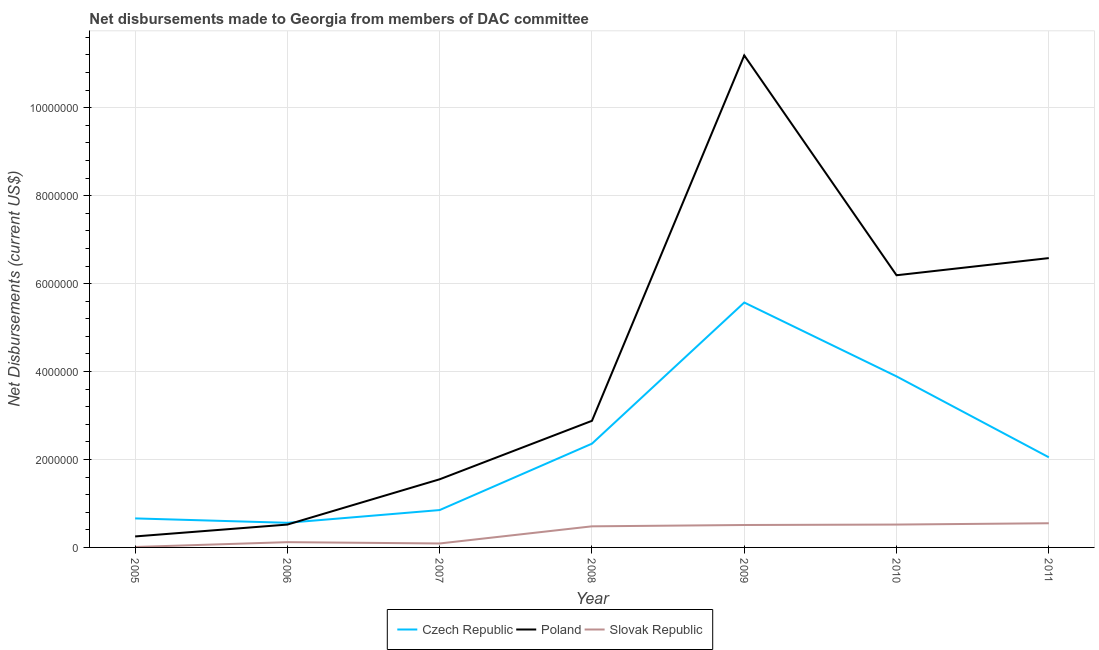What is the net disbursements made by czech republic in 2005?
Offer a terse response. 6.60e+05. Across all years, what is the maximum net disbursements made by czech republic?
Make the answer very short. 5.57e+06. Across all years, what is the minimum net disbursements made by poland?
Offer a very short reply. 2.50e+05. In which year was the net disbursements made by poland maximum?
Your response must be concise. 2009. In which year was the net disbursements made by poland minimum?
Offer a terse response. 2005. What is the total net disbursements made by czech republic in the graph?
Your answer should be very brief. 1.59e+07. What is the difference between the net disbursements made by poland in 2007 and that in 2009?
Keep it short and to the point. -9.64e+06. What is the difference between the net disbursements made by slovak republic in 2010 and the net disbursements made by poland in 2006?
Offer a terse response. 0. What is the average net disbursements made by poland per year?
Your response must be concise. 4.17e+06. In the year 2010, what is the difference between the net disbursements made by poland and net disbursements made by slovak republic?
Make the answer very short. 5.67e+06. What is the ratio of the net disbursements made by poland in 2008 to that in 2009?
Make the answer very short. 0.26. Is the net disbursements made by slovak republic in 2006 less than that in 2008?
Make the answer very short. Yes. Is the difference between the net disbursements made by slovak republic in 2009 and 2011 greater than the difference between the net disbursements made by czech republic in 2009 and 2011?
Provide a short and direct response. No. What is the difference between the highest and the second highest net disbursements made by slovak republic?
Your answer should be very brief. 3.00e+04. What is the difference between the highest and the lowest net disbursements made by slovak republic?
Provide a short and direct response. 5.40e+05. Is the sum of the net disbursements made by slovak republic in 2009 and 2010 greater than the maximum net disbursements made by czech republic across all years?
Offer a terse response. No. Is the net disbursements made by poland strictly less than the net disbursements made by slovak republic over the years?
Offer a terse response. No. How many years are there in the graph?
Ensure brevity in your answer.  7. Where does the legend appear in the graph?
Provide a succinct answer. Bottom center. How are the legend labels stacked?
Keep it short and to the point. Horizontal. What is the title of the graph?
Provide a short and direct response. Net disbursements made to Georgia from members of DAC committee. What is the label or title of the X-axis?
Give a very brief answer. Year. What is the label or title of the Y-axis?
Your answer should be very brief. Net Disbursements (current US$). What is the Net Disbursements (current US$) in Czech Republic in 2005?
Offer a terse response. 6.60e+05. What is the Net Disbursements (current US$) of Slovak Republic in 2005?
Provide a succinct answer. 10000. What is the Net Disbursements (current US$) in Czech Republic in 2006?
Give a very brief answer. 5.60e+05. What is the Net Disbursements (current US$) of Poland in 2006?
Provide a short and direct response. 5.20e+05. What is the Net Disbursements (current US$) of Slovak Republic in 2006?
Keep it short and to the point. 1.20e+05. What is the Net Disbursements (current US$) in Czech Republic in 2007?
Your answer should be very brief. 8.50e+05. What is the Net Disbursements (current US$) of Poland in 2007?
Offer a terse response. 1.55e+06. What is the Net Disbursements (current US$) in Czech Republic in 2008?
Your answer should be compact. 2.36e+06. What is the Net Disbursements (current US$) in Poland in 2008?
Offer a terse response. 2.88e+06. What is the Net Disbursements (current US$) in Slovak Republic in 2008?
Your answer should be compact. 4.80e+05. What is the Net Disbursements (current US$) in Czech Republic in 2009?
Your answer should be compact. 5.57e+06. What is the Net Disbursements (current US$) in Poland in 2009?
Ensure brevity in your answer.  1.12e+07. What is the Net Disbursements (current US$) in Slovak Republic in 2009?
Provide a succinct answer. 5.10e+05. What is the Net Disbursements (current US$) in Czech Republic in 2010?
Offer a very short reply. 3.89e+06. What is the Net Disbursements (current US$) of Poland in 2010?
Offer a very short reply. 6.19e+06. What is the Net Disbursements (current US$) of Slovak Republic in 2010?
Offer a very short reply. 5.20e+05. What is the Net Disbursements (current US$) of Czech Republic in 2011?
Keep it short and to the point. 2.05e+06. What is the Net Disbursements (current US$) in Poland in 2011?
Offer a very short reply. 6.58e+06. What is the Net Disbursements (current US$) of Slovak Republic in 2011?
Keep it short and to the point. 5.50e+05. Across all years, what is the maximum Net Disbursements (current US$) of Czech Republic?
Your answer should be compact. 5.57e+06. Across all years, what is the maximum Net Disbursements (current US$) of Poland?
Keep it short and to the point. 1.12e+07. Across all years, what is the maximum Net Disbursements (current US$) of Slovak Republic?
Your answer should be compact. 5.50e+05. Across all years, what is the minimum Net Disbursements (current US$) of Czech Republic?
Provide a short and direct response. 5.60e+05. Across all years, what is the minimum Net Disbursements (current US$) in Poland?
Your answer should be very brief. 2.50e+05. Across all years, what is the minimum Net Disbursements (current US$) of Slovak Republic?
Make the answer very short. 10000. What is the total Net Disbursements (current US$) of Czech Republic in the graph?
Ensure brevity in your answer.  1.59e+07. What is the total Net Disbursements (current US$) in Poland in the graph?
Your response must be concise. 2.92e+07. What is the total Net Disbursements (current US$) of Slovak Republic in the graph?
Ensure brevity in your answer.  2.28e+06. What is the difference between the Net Disbursements (current US$) in Poland in 2005 and that in 2006?
Offer a terse response. -2.70e+05. What is the difference between the Net Disbursements (current US$) in Poland in 2005 and that in 2007?
Your answer should be very brief. -1.30e+06. What is the difference between the Net Disbursements (current US$) in Czech Republic in 2005 and that in 2008?
Your response must be concise. -1.70e+06. What is the difference between the Net Disbursements (current US$) of Poland in 2005 and that in 2008?
Give a very brief answer. -2.63e+06. What is the difference between the Net Disbursements (current US$) in Slovak Republic in 2005 and that in 2008?
Your response must be concise. -4.70e+05. What is the difference between the Net Disbursements (current US$) in Czech Republic in 2005 and that in 2009?
Your answer should be very brief. -4.91e+06. What is the difference between the Net Disbursements (current US$) in Poland in 2005 and that in 2009?
Provide a short and direct response. -1.09e+07. What is the difference between the Net Disbursements (current US$) in Slovak Republic in 2005 and that in 2009?
Your answer should be very brief. -5.00e+05. What is the difference between the Net Disbursements (current US$) of Czech Republic in 2005 and that in 2010?
Your response must be concise. -3.23e+06. What is the difference between the Net Disbursements (current US$) of Poland in 2005 and that in 2010?
Provide a short and direct response. -5.94e+06. What is the difference between the Net Disbursements (current US$) in Slovak Republic in 2005 and that in 2010?
Give a very brief answer. -5.10e+05. What is the difference between the Net Disbursements (current US$) in Czech Republic in 2005 and that in 2011?
Offer a terse response. -1.39e+06. What is the difference between the Net Disbursements (current US$) in Poland in 2005 and that in 2011?
Offer a terse response. -6.33e+06. What is the difference between the Net Disbursements (current US$) of Slovak Republic in 2005 and that in 2011?
Provide a succinct answer. -5.40e+05. What is the difference between the Net Disbursements (current US$) in Czech Republic in 2006 and that in 2007?
Make the answer very short. -2.90e+05. What is the difference between the Net Disbursements (current US$) in Poland in 2006 and that in 2007?
Provide a succinct answer. -1.03e+06. What is the difference between the Net Disbursements (current US$) in Slovak Republic in 2006 and that in 2007?
Ensure brevity in your answer.  3.00e+04. What is the difference between the Net Disbursements (current US$) of Czech Republic in 2006 and that in 2008?
Give a very brief answer. -1.80e+06. What is the difference between the Net Disbursements (current US$) in Poland in 2006 and that in 2008?
Offer a very short reply. -2.36e+06. What is the difference between the Net Disbursements (current US$) of Slovak Republic in 2006 and that in 2008?
Offer a very short reply. -3.60e+05. What is the difference between the Net Disbursements (current US$) of Czech Republic in 2006 and that in 2009?
Your answer should be compact. -5.01e+06. What is the difference between the Net Disbursements (current US$) in Poland in 2006 and that in 2009?
Offer a terse response. -1.07e+07. What is the difference between the Net Disbursements (current US$) in Slovak Republic in 2006 and that in 2009?
Your response must be concise. -3.90e+05. What is the difference between the Net Disbursements (current US$) in Czech Republic in 2006 and that in 2010?
Offer a terse response. -3.33e+06. What is the difference between the Net Disbursements (current US$) of Poland in 2006 and that in 2010?
Give a very brief answer. -5.67e+06. What is the difference between the Net Disbursements (current US$) of Slovak Republic in 2006 and that in 2010?
Your response must be concise. -4.00e+05. What is the difference between the Net Disbursements (current US$) in Czech Republic in 2006 and that in 2011?
Keep it short and to the point. -1.49e+06. What is the difference between the Net Disbursements (current US$) in Poland in 2006 and that in 2011?
Give a very brief answer. -6.06e+06. What is the difference between the Net Disbursements (current US$) in Slovak Republic in 2006 and that in 2011?
Give a very brief answer. -4.30e+05. What is the difference between the Net Disbursements (current US$) of Czech Republic in 2007 and that in 2008?
Keep it short and to the point. -1.51e+06. What is the difference between the Net Disbursements (current US$) in Poland in 2007 and that in 2008?
Offer a terse response. -1.33e+06. What is the difference between the Net Disbursements (current US$) in Slovak Republic in 2007 and that in 2008?
Make the answer very short. -3.90e+05. What is the difference between the Net Disbursements (current US$) of Czech Republic in 2007 and that in 2009?
Make the answer very short. -4.72e+06. What is the difference between the Net Disbursements (current US$) of Poland in 2007 and that in 2009?
Your response must be concise. -9.64e+06. What is the difference between the Net Disbursements (current US$) in Slovak Republic in 2007 and that in 2009?
Provide a short and direct response. -4.20e+05. What is the difference between the Net Disbursements (current US$) in Czech Republic in 2007 and that in 2010?
Your answer should be very brief. -3.04e+06. What is the difference between the Net Disbursements (current US$) in Poland in 2007 and that in 2010?
Offer a very short reply. -4.64e+06. What is the difference between the Net Disbursements (current US$) of Slovak Republic in 2007 and that in 2010?
Ensure brevity in your answer.  -4.30e+05. What is the difference between the Net Disbursements (current US$) of Czech Republic in 2007 and that in 2011?
Keep it short and to the point. -1.20e+06. What is the difference between the Net Disbursements (current US$) of Poland in 2007 and that in 2011?
Provide a short and direct response. -5.03e+06. What is the difference between the Net Disbursements (current US$) in Slovak Republic in 2007 and that in 2011?
Your answer should be compact. -4.60e+05. What is the difference between the Net Disbursements (current US$) of Czech Republic in 2008 and that in 2009?
Provide a short and direct response. -3.21e+06. What is the difference between the Net Disbursements (current US$) of Poland in 2008 and that in 2009?
Your answer should be compact. -8.31e+06. What is the difference between the Net Disbursements (current US$) of Czech Republic in 2008 and that in 2010?
Keep it short and to the point. -1.53e+06. What is the difference between the Net Disbursements (current US$) of Poland in 2008 and that in 2010?
Offer a terse response. -3.31e+06. What is the difference between the Net Disbursements (current US$) of Slovak Republic in 2008 and that in 2010?
Your answer should be very brief. -4.00e+04. What is the difference between the Net Disbursements (current US$) in Poland in 2008 and that in 2011?
Ensure brevity in your answer.  -3.70e+06. What is the difference between the Net Disbursements (current US$) of Slovak Republic in 2008 and that in 2011?
Provide a succinct answer. -7.00e+04. What is the difference between the Net Disbursements (current US$) of Czech Republic in 2009 and that in 2010?
Your response must be concise. 1.68e+06. What is the difference between the Net Disbursements (current US$) of Czech Republic in 2009 and that in 2011?
Keep it short and to the point. 3.52e+06. What is the difference between the Net Disbursements (current US$) of Poland in 2009 and that in 2011?
Give a very brief answer. 4.61e+06. What is the difference between the Net Disbursements (current US$) of Slovak Republic in 2009 and that in 2011?
Provide a short and direct response. -4.00e+04. What is the difference between the Net Disbursements (current US$) of Czech Republic in 2010 and that in 2011?
Offer a terse response. 1.84e+06. What is the difference between the Net Disbursements (current US$) of Poland in 2010 and that in 2011?
Your response must be concise. -3.90e+05. What is the difference between the Net Disbursements (current US$) in Slovak Republic in 2010 and that in 2011?
Offer a terse response. -3.00e+04. What is the difference between the Net Disbursements (current US$) in Czech Republic in 2005 and the Net Disbursements (current US$) in Poland in 2006?
Your response must be concise. 1.40e+05. What is the difference between the Net Disbursements (current US$) in Czech Republic in 2005 and the Net Disbursements (current US$) in Slovak Republic in 2006?
Provide a short and direct response. 5.40e+05. What is the difference between the Net Disbursements (current US$) of Poland in 2005 and the Net Disbursements (current US$) of Slovak Republic in 2006?
Ensure brevity in your answer.  1.30e+05. What is the difference between the Net Disbursements (current US$) in Czech Republic in 2005 and the Net Disbursements (current US$) in Poland in 2007?
Offer a terse response. -8.90e+05. What is the difference between the Net Disbursements (current US$) of Czech Republic in 2005 and the Net Disbursements (current US$) of Slovak Republic in 2007?
Make the answer very short. 5.70e+05. What is the difference between the Net Disbursements (current US$) of Poland in 2005 and the Net Disbursements (current US$) of Slovak Republic in 2007?
Your answer should be compact. 1.60e+05. What is the difference between the Net Disbursements (current US$) of Czech Republic in 2005 and the Net Disbursements (current US$) of Poland in 2008?
Ensure brevity in your answer.  -2.22e+06. What is the difference between the Net Disbursements (current US$) of Poland in 2005 and the Net Disbursements (current US$) of Slovak Republic in 2008?
Give a very brief answer. -2.30e+05. What is the difference between the Net Disbursements (current US$) in Czech Republic in 2005 and the Net Disbursements (current US$) in Poland in 2009?
Your response must be concise. -1.05e+07. What is the difference between the Net Disbursements (current US$) of Czech Republic in 2005 and the Net Disbursements (current US$) of Poland in 2010?
Make the answer very short. -5.53e+06. What is the difference between the Net Disbursements (current US$) of Czech Republic in 2005 and the Net Disbursements (current US$) of Poland in 2011?
Give a very brief answer. -5.92e+06. What is the difference between the Net Disbursements (current US$) of Czech Republic in 2006 and the Net Disbursements (current US$) of Poland in 2007?
Give a very brief answer. -9.90e+05. What is the difference between the Net Disbursements (current US$) of Poland in 2006 and the Net Disbursements (current US$) of Slovak Republic in 2007?
Ensure brevity in your answer.  4.30e+05. What is the difference between the Net Disbursements (current US$) of Czech Republic in 2006 and the Net Disbursements (current US$) of Poland in 2008?
Provide a short and direct response. -2.32e+06. What is the difference between the Net Disbursements (current US$) of Czech Republic in 2006 and the Net Disbursements (current US$) of Slovak Republic in 2008?
Ensure brevity in your answer.  8.00e+04. What is the difference between the Net Disbursements (current US$) in Czech Republic in 2006 and the Net Disbursements (current US$) in Poland in 2009?
Provide a short and direct response. -1.06e+07. What is the difference between the Net Disbursements (current US$) in Czech Republic in 2006 and the Net Disbursements (current US$) in Poland in 2010?
Give a very brief answer. -5.63e+06. What is the difference between the Net Disbursements (current US$) in Poland in 2006 and the Net Disbursements (current US$) in Slovak Republic in 2010?
Your response must be concise. 0. What is the difference between the Net Disbursements (current US$) in Czech Republic in 2006 and the Net Disbursements (current US$) in Poland in 2011?
Ensure brevity in your answer.  -6.02e+06. What is the difference between the Net Disbursements (current US$) in Poland in 2006 and the Net Disbursements (current US$) in Slovak Republic in 2011?
Keep it short and to the point. -3.00e+04. What is the difference between the Net Disbursements (current US$) of Czech Republic in 2007 and the Net Disbursements (current US$) of Poland in 2008?
Provide a succinct answer. -2.03e+06. What is the difference between the Net Disbursements (current US$) in Czech Republic in 2007 and the Net Disbursements (current US$) in Slovak Republic in 2008?
Your response must be concise. 3.70e+05. What is the difference between the Net Disbursements (current US$) of Poland in 2007 and the Net Disbursements (current US$) of Slovak Republic in 2008?
Your response must be concise. 1.07e+06. What is the difference between the Net Disbursements (current US$) in Czech Republic in 2007 and the Net Disbursements (current US$) in Poland in 2009?
Provide a succinct answer. -1.03e+07. What is the difference between the Net Disbursements (current US$) in Poland in 2007 and the Net Disbursements (current US$) in Slovak Republic in 2009?
Your response must be concise. 1.04e+06. What is the difference between the Net Disbursements (current US$) in Czech Republic in 2007 and the Net Disbursements (current US$) in Poland in 2010?
Keep it short and to the point. -5.34e+06. What is the difference between the Net Disbursements (current US$) of Czech Republic in 2007 and the Net Disbursements (current US$) of Slovak Republic in 2010?
Your answer should be very brief. 3.30e+05. What is the difference between the Net Disbursements (current US$) of Poland in 2007 and the Net Disbursements (current US$) of Slovak Republic in 2010?
Provide a short and direct response. 1.03e+06. What is the difference between the Net Disbursements (current US$) of Czech Republic in 2007 and the Net Disbursements (current US$) of Poland in 2011?
Keep it short and to the point. -5.73e+06. What is the difference between the Net Disbursements (current US$) in Czech Republic in 2008 and the Net Disbursements (current US$) in Poland in 2009?
Ensure brevity in your answer.  -8.83e+06. What is the difference between the Net Disbursements (current US$) in Czech Republic in 2008 and the Net Disbursements (current US$) in Slovak Republic in 2009?
Your answer should be very brief. 1.85e+06. What is the difference between the Net Disbursements (current US$) in Poland in 2008 and the Net Disbursements (current US$) in Slovak Republic in 2009?
Your answer should be very brief. 2.37e+06. What is the difference between the Net Disbursements (current US$) in Czech Republic in 2008 and the Net Disbursements (current US$) in Poland in 2010?
Your answer should be compact. -3.83e+06. What is the difference between the Net Disbursements (current US$) of Czech Republic in 2008 and the Net Disbursements (current US$) of Slovak Republic in 2010?
Ensure brevity in your answer.  1.84e+06. What is the difference between the Net Disbursements (current US$) of Poland in 2008 and the Net Disbursements (current US$) of Slovak Republic in 2010?
Offer a very short reply. 2.36e+06. What is the difference between the Net Disbursements (current US$) of Czech Republic in 2008 and the Net Disbursements (current US$) of Poland in 2011?
Offer a very short reply. -4.22e+06. What is the difference between the Net Disbursements (current US$) in Czech Republic in 2008 and the Net Disbursements (current US$) in Slovak Republic in 2011?
Ensure brevity in your answer.  1.81e+06. What is the difference between the Net Disbursements (current US$) of Poland in 2008 and the Net Disbursements (current US$) of Slovak Republic in 2011?
Your response must be concise. 2.33e+06. What is the difference between the Net Disbursements (current US$) in Czech Republic in 2009 and the Net Disbursements (current US$) in Poland in 2010?
Keep it short and to the point. -6.20e+05. What is the difference between the Net Disbursements (current US$) in Czech Republic in 2009 and the Net Disbursements (current US$) in Slovak Republic in 2010?
Make the answer very short. 5.05e+06. What is the difference between the Net Disbursements (current US$) of Poland in 2009 and the Net Disbursements (current US$) of Slovak Republic in 2010?
Your answer should be compact. 1.07e+07. What is the difference between the Net Disbursements (current US$) of Czech Republic in 2009 and the Net Disbursements (current US$) of Poland in 2011?
Ensure brevity in your answer.  -1.01e+06. What is the difference between the Net Disbursements (current US$) in Czech Republic in 2009 and the Net Disbursements (current US$) in Slovak Republic in 2011?
Keep it short and to the point. 5.02e+06. What is the difference between the Net Disbursements (current US$) of Poland in 2009 and the Net Disbursements (current US$) of Slovak Republic in 2011?
Your response must be concise. 1.06e+07. What is the difference between the Net Disbursements (current US$) of Czech Republic in 2010 and the Net Disbursements (current US$) of Poland in 2011?
Offer a terse response. -2.69e+06. What is the difference between the Net Disbursements (current US$) in Czech Republic in 2010 and the Net Disbursements (current US$) in Slovak Republic in 2011?
Make the answer very short. 3.34e+06. What is the difference between the Net Disbursements (current US$) in Poland in 2010 and the Net Disbursements (current US$) in Slovak Republic in 2011?
Ensure brevity in your answer.  5.64e+06. What is the average Net Disbursements (current US$) of Czech Republic per year?
Your response must be concise. 2.28e+06. What is the average Net Disbursements (current US$) in Poland per year?
Keep it short and to the point. 4.17e+06. What is the average Net Disbursements (current US$) in Slovak Republic per year?
Your response must be concise. 3.26e+05. In the year 2005, what is the difference between the Net Disbursements (current US$) of Czech Republic and Net Disbursements (current US$) of Slovak Republic?
Your answer should be very brief. 6.50e+05. In the year 2005, what is the difference between the Net Disbursements (current US$) of Poland and Net Disbursements (current US$) of Slovak Republic?
Give a very brief answer. 2.40e+05. In the year 2006, what is the difference between the Net Disbursements (current US$) of Czech Republic and Net Disbursements (current US$) of Poland?
Provide a succinct answer. 4.00e+04. In the year 2006, what is the difference between the Net Disbursements (current US$) of Czech Republic and Net Disbursements (current US$) of Slovak Republic?
Keep it short and to the point. 4.40e+05. In the year 2006, what is the difference between the Net Disbursements (current US$) in Poland and Net Disbursements (current US$) in Slovak Republic?
Give a very brief answer. 4.00e+05. In the year 2007, what is the difference between the Net Disbursements (current US$) of Czech Republic and Net Disbursements (current US$) of Poland?
Provide a succinct answer. -7.00e+05. In the year 2007, what is the difference between the Net Disbursements (current US$) in Czech Republic and Net Disbursements (current US$) in Slovak Republic?
Offer a terse response. 7.60e+05. In the year 2007, what is the difference between the Net Disbursements (current US$) of Poland and Net Disbursements (current US$) of Slovak Republic?
Give a very brief answer. 1.46e+06. In the year 2008, what is the difference between the Net Disbursements (current US$) in Czech Republic and Net Disbursements (current US$) in Poland?
Keep it short and to the point. -5.20e+05. In the year 2008, what is the difference between the Net Disbursements (current US$) in Czech Republic and Net Disbursements (current US$) in Slovak Republic?
Your answer should be very brief. 1.88e+06. In the year 2008, what is the difference between the Net Disbursements (current US$) in Poland and Net Disbursements (current US$) in Slovak Republic?
Provide a succinct answer. 2.40e+06. In the year 2009, what is the difference between the Net Disbursements (current US$) in Czech Republic and Net Disbursements (current US$) in Poland?
Keep it short and to the point. -5.62e+06. In the year 2009, what is the difference between the Net Disbursements (current US$) of Czech Republic and Net Disbursements (current US$) of Slovak Republic?
Ensure brevity in your answer.  5.06e+06. In the year 2009, what is the difference between the Net Disbursements (current US$) of Poland and Net Disbursements (current US$) of Slovak Republic?
Your answer should be very brief. 1.07e+07. In the year 2010, what is the difference between the Net Disbursements (current US$) in Czech Republic and Net Disbursements (current US$) in Poland?
Keep it short and to the point. -2.30e+06. In the year 2010, what is the difference between the Net Disbursements (current US$) of Czech Republic and Net Disbursements (current US$) of Slovak Republic?
Offer a very short reply. 3.37e+06. In the year 2010, what is the difference between the Net Disbursements (current US$) of Poland and Net Disbursements (current US$) of Slovak Republic?
Provide a succinct answer. 5.67e+06. In the year 2011, what is the difference between the Net Disbursements (current US$) of Czech Republic and Net Disbursements (current US$) of Poland?
Your response must be concise. -4.53e+06. In the year 2011, what is the difference between the Net Disbursements (current US$) in Czech Republic and Net Disbursements (current US$) in Slovak Republic?
Keep it short and to the point. 1.50e+06. In the year 2011, what is the difference between the Net Disbursements (current US$) of Poland and Net Disbursements (current US$) of Slovak Republic?
Your response must be concise. 6.03e+06. What is the ratio of the Net Disbursements (current US$) of Czech Republic in 2005 to that in 2006?
Keep it short and to the point. 1.18. What is the ratio of the Net Disbursements (current US$) in Poland in 2005 to that in 2006?
Ensure brevity in your answer.  0.48. What is the ratio of the Net Disbursements (current US$) of Slovak Republic in 2005 to that in 2006?
Keep it short and to the point. 0.08. What is the ratio of the Net Disbursements (current US$) of Czech Republic in 2005 to that in 2007?
Offer a terse response. 0.78. What is the ratio of the Net Disbursements (current US$) of Poland in 2005 to that in 2007?
Your response must be concise. 0.16. What is the ratio of the Net Disbursements (current US$) of Czech Republic in 2005 to that in 2008?
Provide a short and direct response. 0.28. What is the ratio of the Net Disbursements (current US$) of Poland in 2005 to that in 2008?
Ensure brevity in your answer.  0.09. What is the ratio of the Net Disbursements (current US$) of Slovak Republic in 2005 to that in 2008?
Your response must be concise. 0.02. What is the ratio of the Net Disbursements (current US$) in Czech Republic in 2005 to that in 2009?
Give a very brief answer. 0.12. What is the ratio of the Net Disbursements (current US$) in Poland in 2005 to that in 2009?
Your answer should be very brief. 0.02. What is the ratio of the Net Disbursements (current US$) of Slovak Republic in 2005 to that in 2009?
Ensure brevity in your answer.  0.02. What is the ratio of the Net Disbursements (current US$) in Czech Republic in 2005 to that in 2010?
Your answer should be very brief. 0.17. What is the ratio of the Net Disbursements (current US$) of Poland in 2005 to that in 2010?
Offer a very short reply. 0.04. What is the ratio of the Net Disbursements (current US$) of Slovak Republic in 2005 to that in 2010?
Offer a terse response. 0.02. What is the ratio of the Net Disbursements (current US$) of Czech Republic in 2005 to that in 2011?
Ensure brevity in your answer.  0.32. What is the ratio of the Net Disbursements (current US$) of Poland in 2005 to that in 2011?
Keep it short and to the point. 0.04. What is the ratio of the Net Disbursements (current US$) of Slovak Republic in 2005 to that in 2011?
Provide a short and direct response. 0.02. What is the ratio of the Net Disbursements (current US$) in Czech Republic in 2006 to that in 2007?
Offer a very short reply. 0.66. What is the ratio of the Net Disbursements (current US$) in Poland in 2006 to that in 2007?
Provide a succinct answer. 0.34. What is the ratio of the Net Disbursements (current US$) of Czech Republic in 2006 to that in 2008?
Offer a terse response. 0.24. What is the ratio of the Net Disbursements (current US$) in Poland in 2006 to that in 2008?
Give a very brief answer. 0.18. What is the ratio of the Net Disbursements (current US$) in Slovak Republic in 2006 to that in 2008?
Ensure brevity in your answer.  0.25. What is the ratio of the Net Disbursements (current US$) in Czech Republic in 2006 to that in 2009?
Make the answer very short. 0.1. What is the ratio of the Net Disbursements (current US$) in Poland in 2006 to that in 2009?
Provide a short and direct response. 0.05. What is the ratio of the Net Disbursements (current US$) of Slovak Republic in 2006 to that in 2009?
Your answer should be very brief. 0.24. What is the ratio of the Net Disbursements (current US$) of Czech Republic in 2006 to that in 2010?
Give a very brief answer. 0.14. What is the ratio of the Net Disbursements (current US$) in Poland in 2006 to that in 2010?
Keep it short and to the point. 0.08. What is the ratio of the Net Disbursements (current US$) in Slovak Republic in 2006 to that in 2010?
Your answer should be very brief. 0.23. What is the ratio of the Net Disbursements (current US$) of Czech Republic in 2006 to that in 2011?
Provide a short and direct response. 0.27. What is the ratio of the Net Disbursements (current US$) of Poland in 2006 to that in 2011?
Keep it short and to the point. 0.08. What is the ratio of the Net Disbursements (current US$) of Slovak Republic in 2006 to that in 2011?
Ensure brevity in your answer.  0.22. What is the ratio of the Net Disbursements (current US$) in Czech Republic in 2007 to that in 2008?
Your response must be concise. 0.36. What is the ratio of the Net Disbursements (current US$) of Poland in 2007 to that in 2008?
Your answer should be very brief. 0.54. What is the ratio of the Net Disbursements (current US$) in Slovak Republic in 2007 to that in 2008?
Ensure brevity in your answer.  0.19. What is the ratio of the Net Disbursements (current US$) in Czech Republic in 2007 to that in 2009?
Offer a terse response. 0.15. What is the ratio of the Net Disbursements (current US$) in Poland in 2007 to that in 2009?
Offer a very short reply. 0.14. What is the ratio of the Net Disbursements (current US$) of Slovak Republic in 2007 to that in 2009?
Give a very brief answer. 0.18. What is the ratio of the Net Disbursements (current US$) in Czech Republic in 2007 to that in 2010?
Provide a succinct answer. 0.22. What is the ratio of the Net Disbursements (current US$) in Poland in 2007 to that in 2010?
Provide a short and direct response. 0.25. What is the ratio of the Net Disbursements (current US$) in Slovak Republic in 2007 to that in 2010?
Provide a succinct answer. 0.17. What is the ratio of the Net Disbursements (current US$) in Czech Republic in 2007 to that in 2011?
Offer a terse response. 0.41. What is the ratio of the Net Disbursements (current US$) of Poland in 2007 to that in 2011?
Your answer should be very brief. 0.24. What is the ratio of the Net Disbursements (current US$) in Slovak Republic in 2007 to that in 2011?
Provide a succinct answer. 0.16. What is the ratio of the Net Disbursements (current US$) of Czech Republic in 2008 to that in 2009?
Provide a succinct answer. 0.42. What is the ratio of the Net Disbursements (current US$) in Poland in 2008 to that in 2009?
Keep it short and to the point. 0.26. What is the ratio of the Net Disbursements (current US$) of Czech Republic in 2008 to that in 2010?
Provide a short and direct response. 0.61. What is the ratio of the Net Disbursements (current US$) of Poland in 2008 to that in 2010?
Your answer should be very brief. 0.47. What is the ratio of the Net Disbursements (current US$) in Czech Republic in 2008 to that in 2011?
Ensure brevity in your answer.  1.15. What is the ratio of the Net Disbursements (current US$) of Poland in 2008 to that in 2011?
Ensure brevity in your answer.  0.44. What is the ratio of the Net Disbursements (current US$) in Slovak Republic in 2008 to that in 2011?
Provide a short and direct response. 0.87. What is the ratio of the Net Disbursements (current US$) in Czech Republic in 2009 to that in 2010?
Provide a succinct answer. 1.43. What is the ratio of the Net Disbursements (current US$) in Poland in 2009 to that in 2010?
Your answer should be compact. 1.81. What is the ratio of the Net Disbursements (current US$) of Slovak Republic in 2009 to that in 2010?
Keep it short and to the point. 0.98. What is the ratio of the Net Disbursements (current US$) in Czech Republic in 2009 to that in 2011?
Provide a succinct answer. 2.72. What is the ratio of the Net Disbursements (current US$) of Poland in 2009 to that in 2011?
Provide a short and direct response. 1.7. What is the ratio of the Net Disbursements (current US$) of Slovak Republic in 2009 to that in 2011?
Provide a short and direct response. 0.93. What is the ratio of the Net Disbursements (current US$) in Czech Republic in 2010 to that in 2011?
Your response must be concise. 1.9. What is the ratio of the Net Disbursements (current US$) in Poland in 2010 to that in 2011?
Provide a succinct answer. 0.94. What is the ratio of the Net Disbursements (current US$) in Slovak Republic in 2010 to that in 2011?
Offer a terse response. 0.95. What is the difference between the highest and the second highest Net Disbursements (current US$) in Czech Republic?
Give a very brief answer. 1.68e+06. What is the difference between the highest and the second highest Net Disbursements (current US$) in Poland?
Your answer should be compact. 4.61e+06. What is the difference between the highest and the second highest Net Disbursements (current US$) in Slovak Republic?
Make the answer very short. 3.00e+04. What is the difference between the highest and the lowest Net Disbursements (current US$) in Czech Republic?
Provide a succinct answer. 5.01e+06. What is the difference between the highest and the lowest Net Disbursements (current US$) of Poland?
Offer a terse response. 1.09e+07. What is the difference between the highest and the lowest Net Disbursements (current US$) of Slovak Republic?
Ensure brevity in your answer.  5.40e+05. 